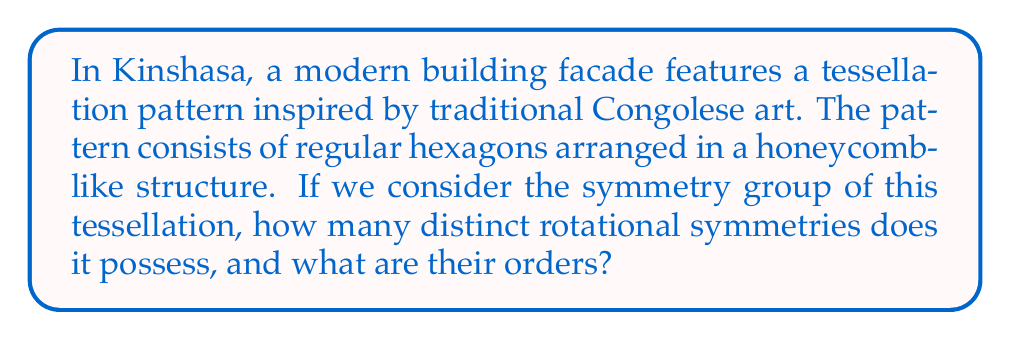Can you answer this question? To analyze the symmetry group of this hexagonal tessellation, we need to consider the rotational symmetries of a regular hexagon:

1. The center of rotation is at the center of any hexagon in the pattern.

2. The possible rotations are:
   - 60° (1/6 of a full rotation)
   - 120° (1/3 of a full rotation)
   - 180° (1/2 of a full rotation)
   - 240° (2/3 of a full rotation)
   - 300° (5/6 of a full rotation)
   - 360° (full rotation, identity)

3. The order of a rotational symmetry is the number of times the rotation needs to be applied to return to the starting position. For a rotation of angle $\theta$, the order is given by:

   $$ \text{order} = \frac{360°}{\theta} $$

4. Calculating the orders:
   - 60° rotation: order = 360° / 60° = 6
   - 120° rotation: order = 360° / 120° = 3
   - 180° rotation: order = 360° / 180° = 2
   - 240° rotation: order = 360° / 240° = 3/2 (not an integer, so this is equivalent to the 120° rotation)
   - 300° rotation: order = 360° / 300° = 6/5 (not an integer, so this is equivalent to the 60° rotation)
   - 360° rotation: order = 360° / 360° = 1 (identity)

5. The distinct rotational symmetries are those with unique orders: 60° (order 6), 120° (order 3), 180° (order 2), and 360° (order 1, identity).

Therefore, there are 4 distinct rotational symmetries in the symmetry group of this hexagonal tessellation pattern.
Answer: The hexagonal tessellation pattern has 4 distinct rotational symmetries with orders 1, 2, 3, and 6. 